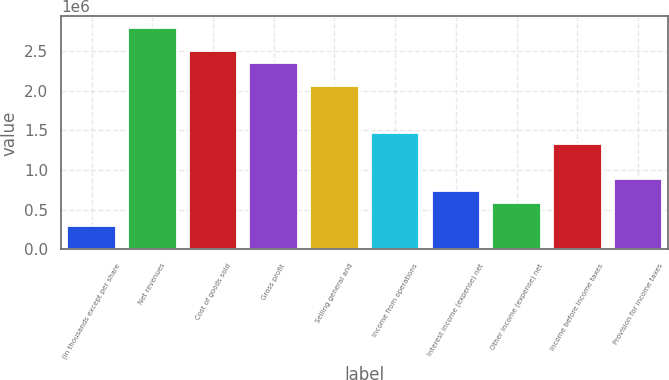Convert chart to OTSL. <chart><loc_0><loc_0><loc_500><loc_500><bar_chart><fcel>(In thousands except per share<fcel>Net revenues<fcel>Cost of goods sold<fcel>Gross profit<fcel>Selling general and<fcel>Income from operations<fcel>Interest income (expense) net<fcel>Other income (expense) net<fcel>Income before income taxes<fcel>Provision for income taxes<nl><fcel>294538<fcel>2.7981e+06<fcel>2.50356e+06<fcel>2.35629e+06<fcel>2.06176e+06<fcel>1.47268e+06<fcel>736343<fcel>589075<fcel>1.32542e+06<fcel>883611<nl></chart> 